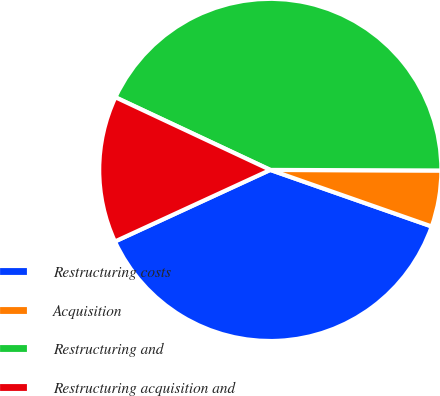<chart> <loc_0><loc_0><loc_500><loc_500><pie_chart><fcel>Restructuring costs<fcel>Acquisition<fcel>Restructuring and<fcel>Restructuring acquisition and<nl><fcel>37.76%<fcel>5.31%<fcel>43.07%<fcel>13.85%<nl></chart> 